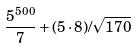<formula> <loc_0><loc_0><loc_500><loc_500>\frac { 5 ^ { 5 0 0 } } { 7 } + ( 5 \cdot 8 ) / \sqrt { 1 7 0 }</formula> 